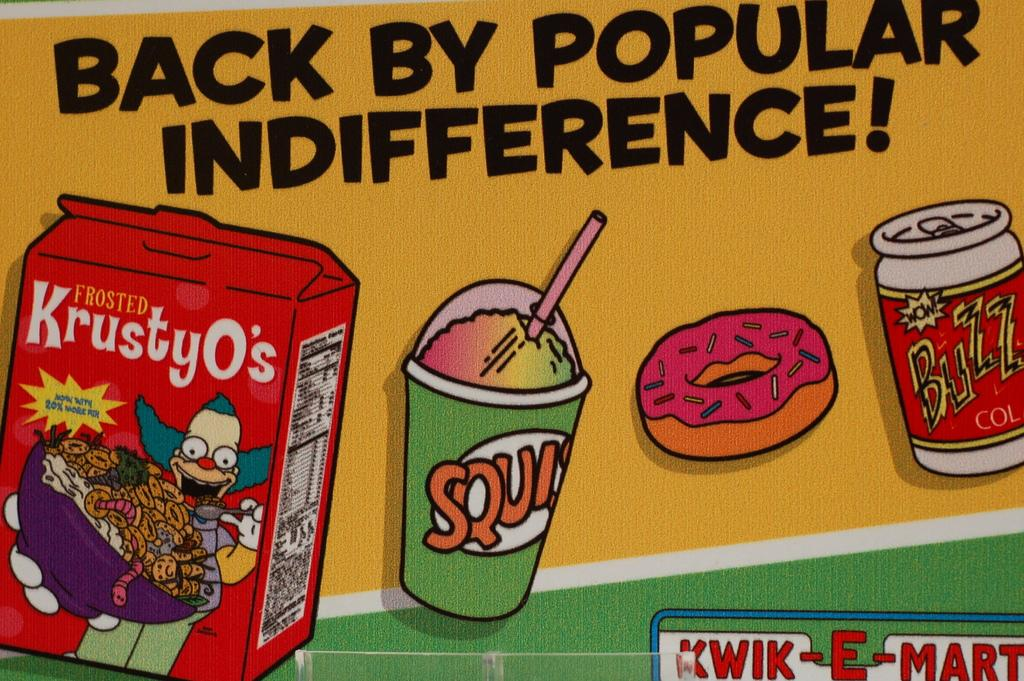<image>
Write a terse but informative summary of the picture. A poster with images from the popular TV show The Simpson's is titles Back by popular indifference. 